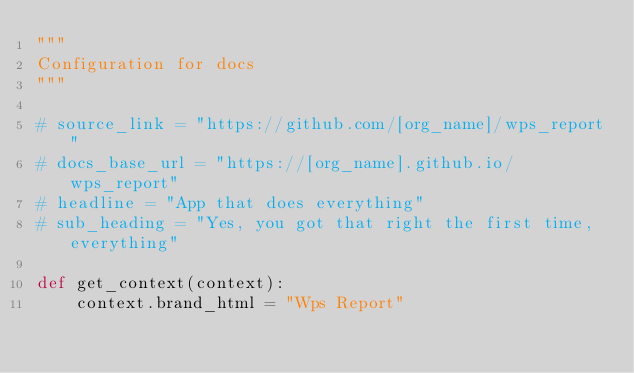Convert code to text. <code><loc_0><loc_0><loc_500><loc_500><_Python_>"""
Configuration for docs
"""

# source_link = "https://github.com/[org_name]/wps_report"
# docs_base_url = "https://[org_name].github.io/wps_report"
# headline = "App that does everything"
# sub_heading = "Yes, you got that right the first time, everything"

def get_context(context):
	context.brand_html = "Wps Report"
</code> 